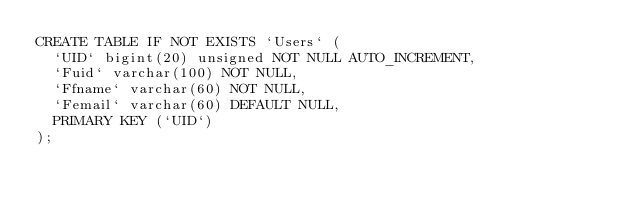<code> <loc_0><loc_0><loc_500><loc_500><_SQL_>CREATE TABLE IF NOT EXISTS `Users` (
  `UID` bigint(20) unsigned NOT NULL AUTO_INCREMENT,
  `Fuid` varchar(100) NOT NULL,
  `Ffname` varchar(60) NOT NULL,
  `Femail` varchar(60) DEFAULT NULL,
  PRIMARY KEY (`UID`)
);</code> 